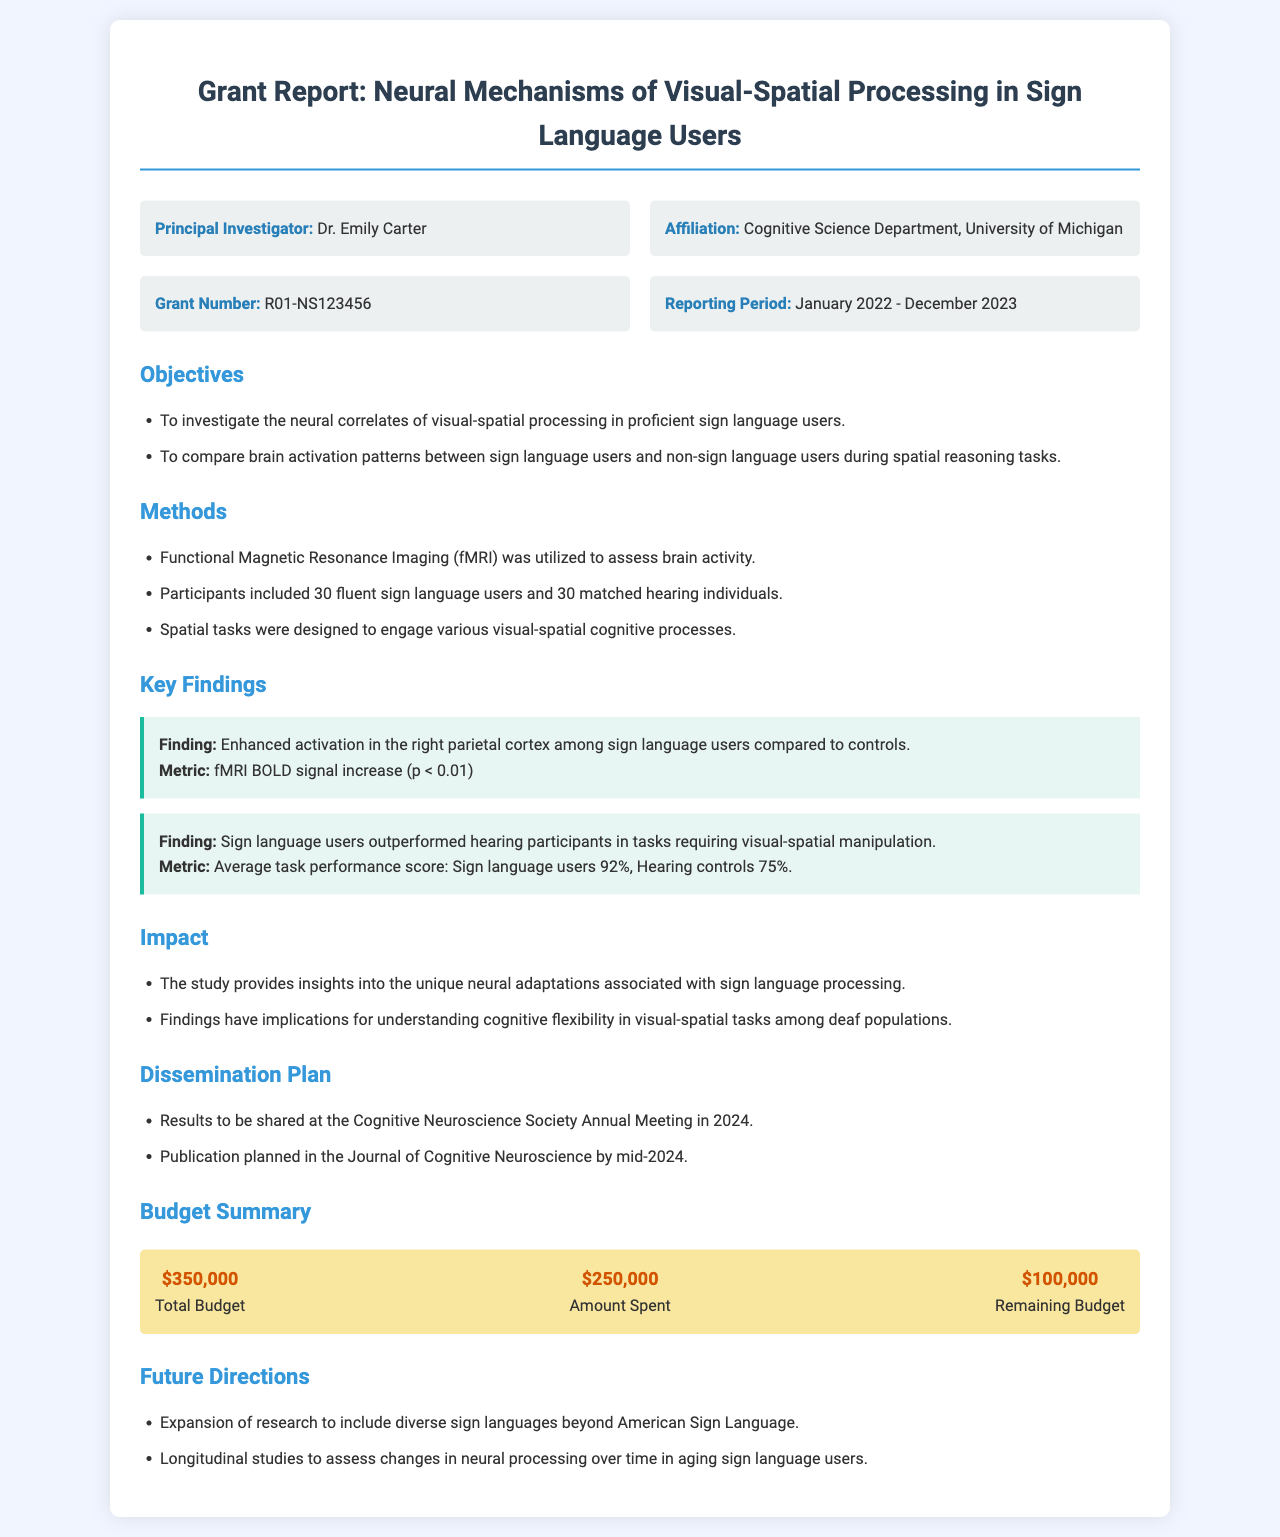What is the principal investigator's name? The principal investigator's name is listed in the document, which is Dr. Emily Carter.
Answer: Dr. Emily Carter What was the reporting period for the project? The reporting period is specified in the document, from January 2022 to December 2023.
Answer: January 2022 - December 2023 How many participants were fluent sign language users? The number of participants who were fluent sign language users is provided, which is 30.
Answer: 30 What percentage did sign language users achieve in task performance? This percentage is noted in the key findings, indicating that sign language users achieved 92%.
Answer: 92% Which brain region showed enhanced activation among sign language users? The specific brain region that showed enhanced activation is detailed in the findings, which is the right parietal cortex.
Answer: right parietal cortex What is the total budget for the project? The total budget is mentioned in the budget summary, which amounts to $350,000.
Answer: $350,000 What publication is planned for the results? The document states that the publication is planned in the Journal of Cognitive Neuroscience.
Answer: Journal of Cognitive Neuroscience What is one future direction mentioned for the research? The future directions section provides various ideas, including expansion to diverse sign languages.
Answer: Expansion to diverse sign languages 